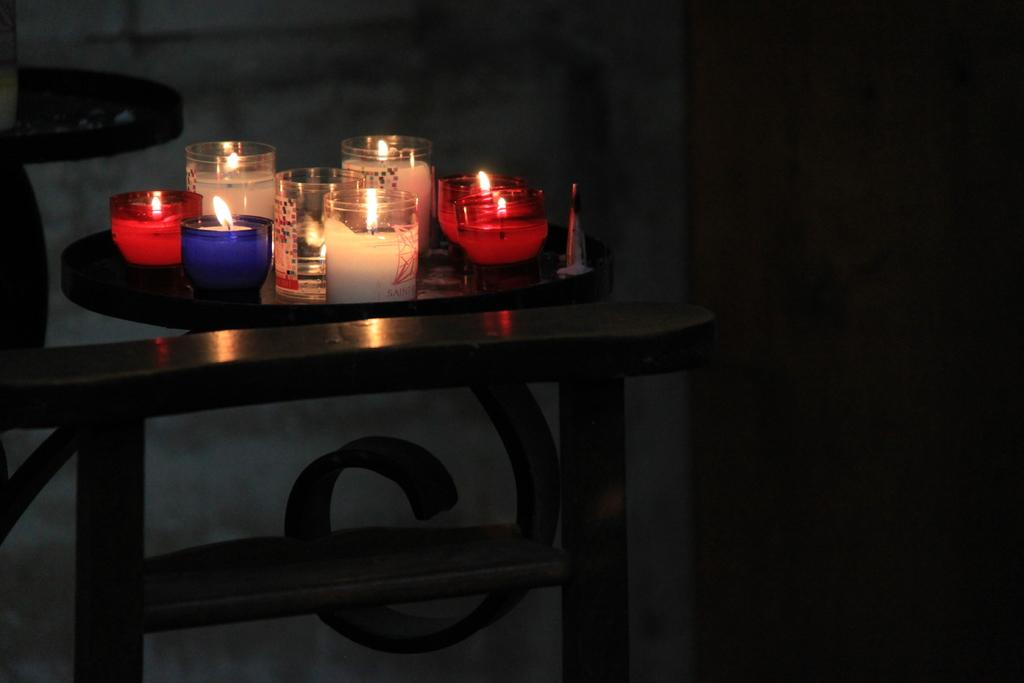What type of material is present in the image? There is glass in the image. What is the source of light in the image? There is a candle in the image. What type of glasses can be seen in the image? There are colorful glasses in the image. How are the objects arranged in the image? The objects are arranged in an order. What is the surface on which the objects are placed? The objects are on a wooden table. What type of disease is being treated in the image? There is no disease or treatment present in the image; it features glass, a candle, colorful glasses, and a wooden table. What type of scientific experiment is being conducted in the image? There is no scientific experiment or equipment present in the image. 